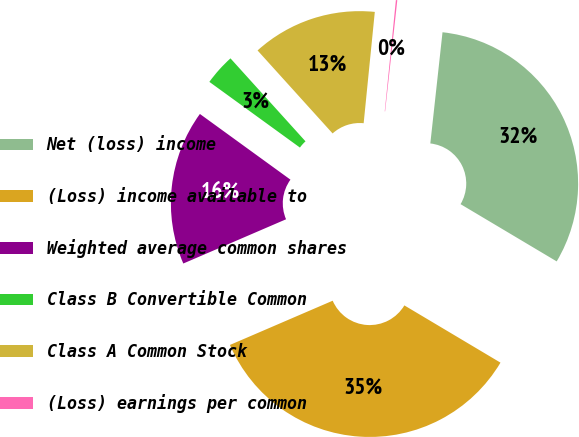Convert chart to OTSL. <chart><loc_0><loc_0><loc_500><loc_500><pie_chart><fcel>Net (loss) income<fcel>(Loss) income available to<fcel>Weighted average common shares<fcel>Class B Convertible Common<fcel>Class A Common Stock<fcel>(Loss) earnings per common<nl><fcel>31.81%<fcel>34.98%<fcel>16.46%<fcel>3.31%<fcel>13.29%<fcel>0.15%<nl></chart> 